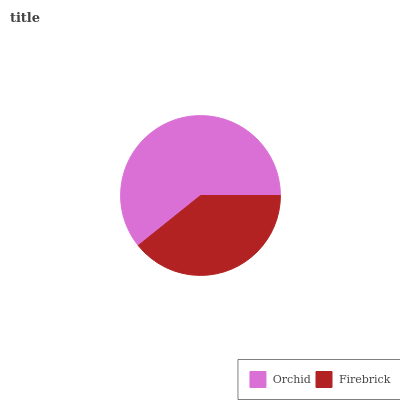Is Firebrick the minimum?
Answer yes or no. Yes. Is Orchid the maximum?
Answer yes or no. Yes. Is Firebrick the maximum?
Answer yes or no. No. Is Orchid greater than Firebrick?
Answer yes or no. Yes. Is Firebrick less than Orchid?
Answer yes or no. Yes. Is Firebrick greater than Orchid?
Answer yes or no. No. Is Orchid less than Firebrick?
Answer yes or no. No. Is Orchid the high median?
Answer yes or no. Yes. Is Firebrick the low median?
Answer yes or no. Yes. Is Firebrick the high median?
Answer yes or no. No. Is Orchid the low median?
Answer yes or no. No. 